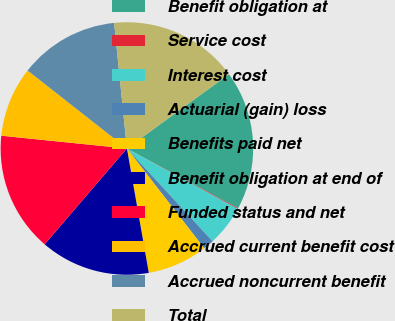<chart> <loc_0><loc_0><loc_500><loc_500><pie_chart><fcel>Benefit obligation at<fcel>Service cost<fcel>Interest cost<fcel>Actuarial (gain) loss<fcel>Benefits paid net<fcel>Benefit obligation at end of<fcel>Funded status and net<fcel>Accrued current benefit cost<fcel>Accrued noncurrent benefit<fcel>Total<nl><fcel>17.87%<fcel>0.1%<fcel>5.18%<fcel>1.37%<fcel>7.72%<fcel>14.06%<fcel>15.33%<fcel>8.98%<fcel>12.79%<fcel>16.6%<nl></chart> 